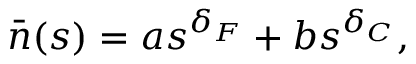Convert formula to latex. <formula><loc_0><loc_0><loc_500><loc_500>\bar { n } ( s ) = a s ^ { \delta _ { F } } + b s ^ { \delta _ { C } } ,</formula> 